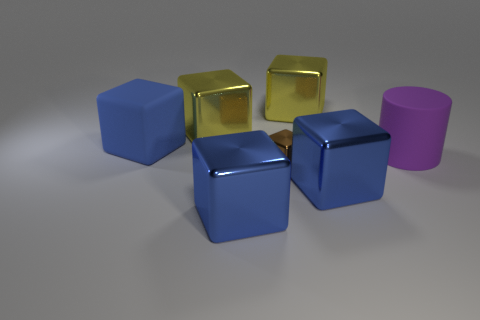Subtract all red balls. How many blue blocks are left? 3 Subtract all brown cubes. How many cubes are left? 5 Subtract all rubber cubes. How many cubes are left? 5 Subtract all brown blocks. Subtract all yellow balls. How many blocks are left? 5 Add 3 large yellow objects. How many objects exist? 10 Subtract all cylinders. How many objects are left? 6 Add 4 large blocks. How many large blocks are left? 9 Add 2 big purple rubber cylinders. How many big purple rubber cylinders exist? 3 Subtract 0 green spheres. How many objects are left? 7 Subtract all cylinders. Subtract all tiny shiny things. How many objects are left? 5 